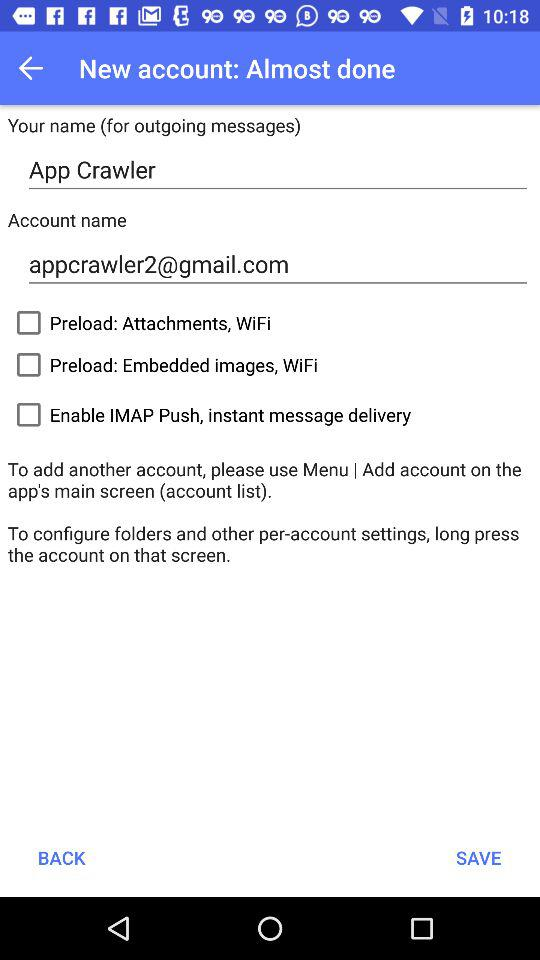How many input fields are there for user information?
Answer the question using a single word or phrase. 2 